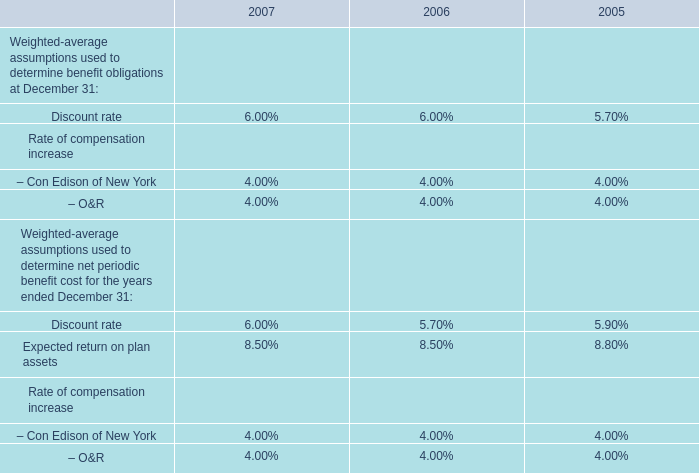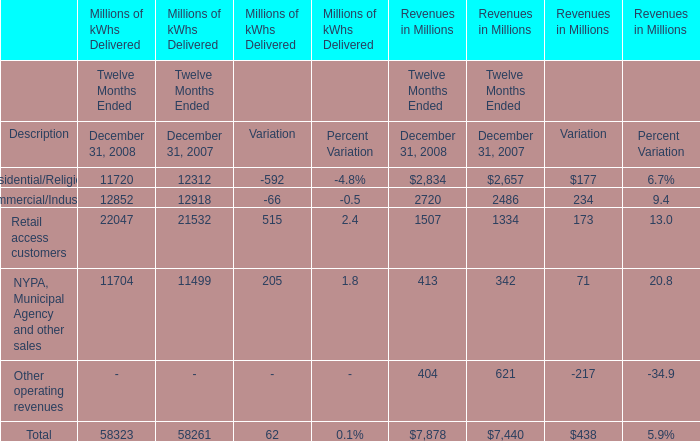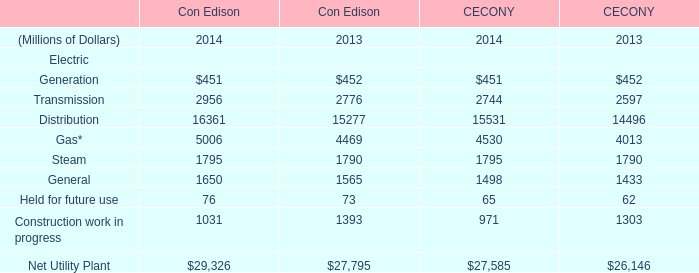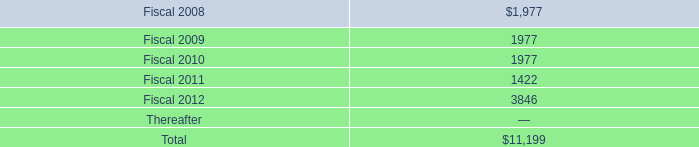When does Residential/Religious in revenues reach the largest value? 
Answer: 2008. 